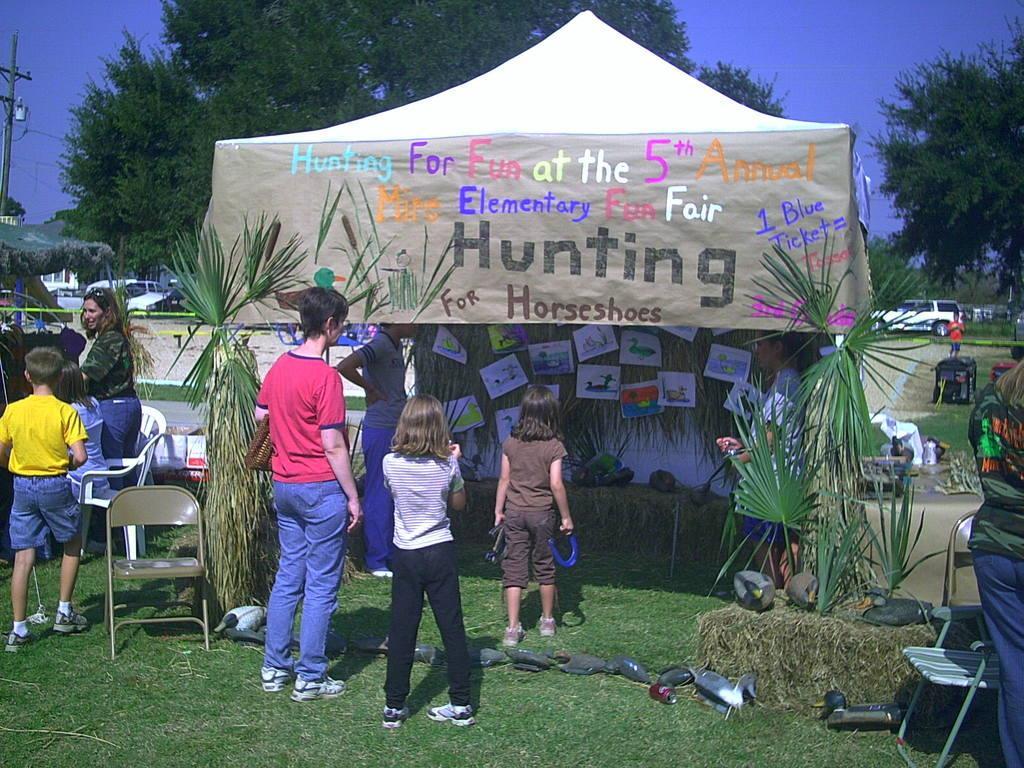Can you describe this image briefly? This picture is clicked outside. In the foreground we can see the green grass, chairs, group of persons and there are some objects lying on the ground and we can see the green leaves and we can see the text and some numbers and some pictures on the tent and we can see the posts containing pictures of some objects and many other object. In the background we can see the sky, trees, vehicles, pole and many other objects. 